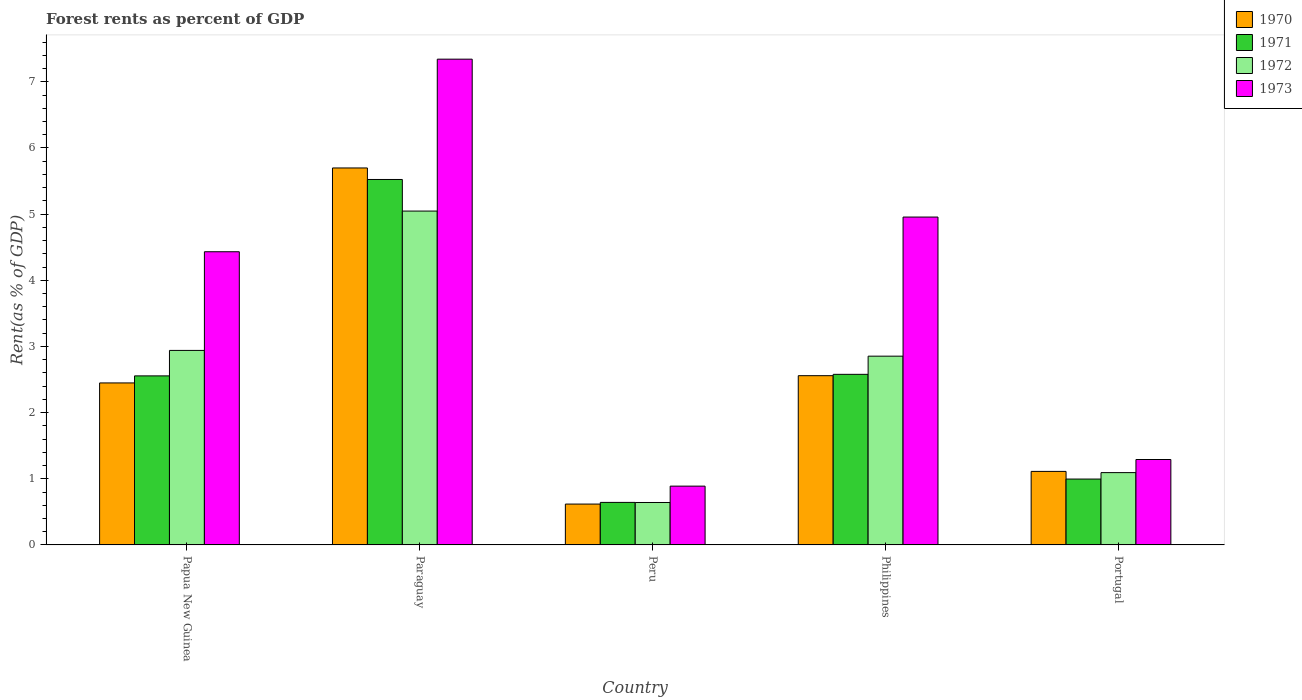How many groups of bars are there?
Your answer should be very brief. 5. How many bars are there on the 4th tick from the left?
Provide a succinct answer. 4. How many bars are there on the 2nd tick from the right?
Offer a very short reply. 4. What is the label of the 2nd group of bars from the left?
Ensure brevity in your answer.  Paraguay. In how many cases, is the number of bars for a given country not equal to the number of legend labels?
Your answer should be very brief. 0. What is the forest rent in 1970 in Paraguay?
Your response must be concise. 5.7. Across all countries, what is the maximum forest rent in 1970?
Your response must be concise. 5.7. Across all countries, what is the minimum forest rent in 1973?
Keep it short and to the point. 0.89. In which country was the forest rent in 1973 maximum?
Offer a very short reply. Paraguay. In which country was the forest rent in 1972 minimum?
Make the answer very short. Peru. What is the total forest rent in 1971 in the graph?
Give a very brief answer. 12.3. What is the difference between the forest rent in 1973 in Paraguay and that in Philippines?
Offer a very short reply. 2.39. What is the difference between the forest rent in 1971 in Paraguay and the forest rent in 1973 in Peru?
Ensure brevity in your answer.  4.64. What is the average forest rent in 1972 per country?
Ensure brevity in your answer.  2.51. What is the difference between the forest rent of/in 1973 and forest rent of/in 1970 in Paraguay?
Your answer should be very brief. 1.64. In how many countries, is the forest rent in 1973 greater than 1 %?
Your answer should be very brief. 4. What is the ratio of the forest rent in 1971 in Peru to that in Philippines?
Offer a terse response. 0.25. Is the forest rent in 1971 in Papua New Guinea less than that in Paraguay?
Give a very brief answer. Yes. Is the difference between the forest rent in 1973 in Papua New Guinea and Portugal greater than the difference between the forest rent in 1970 in Papua New Guinea and Portugal?
Your answer should be compact. Yes. What is the difference between the highest and the second highest forest rent in 1971?
Your answer should be compact. 0.02. What is the difference between the highest and the lowest forest rent in 1972?
Your answer should be very brief. 4.41. Is the sum of the forest rent in 1973 in Peru and Portugal greater than the maximum forest rent in 1970 across all countries?
Offer a terse response. No. What does the 2nd bar from the left in Philippines represents?
Offer a terse response. 1971. What is the difference between two consecutive major ticks on the Y-axis?
Make the answer very short. 1. Does the graph contain any zero values?
Ensure brevity in your answer.  No. Does the graph contain grids?
Offer a terse response. No. How many legend labels are there?
Ensure brevity in your answer.  4. What is the title of the graph?
Offer a terse response. Forest rents as percent of GDP. What is the label or title of the Y-axis?
Your answer should be compact. Rent(as % of GDP). What is the Rent(as % of GDP) of 1970 in Papua New Guinea?
Give a very brief answer. 2.45. What is the Rent(as % of GDP) of 1971 in Papua New Guinea?
Provide a succinct answer. 2.56. What is the Rent(as % of GDP) of 1972 in Papua New Guinea?
Give a very brief answer. 2.94. What is the Rent(as % of GDP) of 1973 in Papua New Guinea?
Provide a succinct answer. 4.43. What is the Rent(as % of GDP) in 1970 in Paraguay?
Provide a succinct answer. 5.7. What is the Rent(as % of GDP) of 1971 in Paraguay?
Your response must be concise. 5.52. What is the Rent(as % of GDP) of 1972 in Paraguay?
Give a very brief answer. 5.05. What is the Rent(as % of GDP) in 1973 in Paraguay?
Give a very brief answer. 7.34. What is the Rent(as % of GDP) of 1970 in Peru?
Give a very brief answer. 0.62. What is the Rent(as % of GDP) of 1971 in Peru?
Your answer should be compact. 0.64. What is the Rent(as % of GDP) of 1972 in Peru?
Give a very brief answer. 0.64. What is the Rent(as % of GDP) of 1973 in Peru?
Give a very brief answer. 0.89. What is the Rent(as % of GDP) of 1970 in Philippines?
Make the answer very short. 2.56. What is the Rent(as % of GDP) of 1971 in Philippines?
Provide a short and direct response. 2.58. What is the Rent(as % of GDP) in 1972 in Philippines?
Offer a very short reply. 2.85. What is the Rent(as % of GDP) in 1973 in Philippines?
Your answer should be compact. 4.96. What is the Rent(as % of GDP) of 1970 in Portugal?
Your answer should be compact. 1.11. What is the Rent(as % of GDP) in 1971 in Portugal?
Offer a terse response. 1. What is the Rent(as % of GDP) in 1972 in Portugal?
Ensure brevity in your answer.  1.09. What is the Rent(as % of GDP) of 1973 in Portugal?
Ensure brevity in your answer.  1.29. Across all countries, what is the maximum Rent(as % of GDP) of 1970?
Your response must be concise. 5.7. Across all countries, what is the maximum Rent(as % of GDP) in 1971?
Your answer should be compact. 5.52. Across all countries, what is the maximum Rent(as % of GDP) of 1972?
Make the answer very short. 5.05. Across all countries, what is the maximum Rent(as % of GDP) of 1973?
Offer a very short reply. 7.34. Across all countries, what is the minimum Rent(as % of GDP) of 1970?
Your response must be concise. 0.62. Across all countries, what is the minimum Rent(as % of GDP) of 1971?
Offer a very short reply. 0.64. Across all countries, what is the minimum Rent(as % of GDP) in 1972?
Keep it short and to the point. 0.64. Across all countries, what is the minimum Rent(as % of GDP) in 1973?
Make the answer very short. 0.89. What is the total Rent(as % of GDP) of 1970 in the graph?
Your answer should be compact. 12.43. What is the total Rent(as % of GDP) in 1971 in the graph?
Your answer should be compact. 12.3. What is the total Rent(as % of GDP) in 1972 in the graph?
Provide a succinct answer. 12.57. What is the total Rent(as % of GDP) of 1973 in the graph?
Keep it short and to the point. 18.91. What is the difference between the Rent(as % of GDP) in 1970 in Papua New Guinea and that in Paraguay?
Your answer should be very brief. -3.25. What is the difference between the Rent(as % of GDP) in 1971 in Papua New Guinea and that in Paraguay?
Ensure brevity in your answer.  -2.97. What is the difference between the Rent(as % of GDP) in 1972 in Papua New Guinea and that in Paraguay?
Offer a terse response. -2.11. What is the difference between the Rent(as % of GDP) in 1973 in Papua New Guinea and that in Paraguay?
Offer a terse response. -2.91. What is the difference between the Rent(as % of GDP) of 1970 in Papua New Guinea and that in Peru?
Provide a succinct answer. 1.83. What is the difference between the Rent(as % of GDP) in 1971 in Papua New Guinea and that in Peru?
Your response must be concise. 1.91. What is the difference between the Rent(as % of GDP) of 1972 in Papua New Guinea and that in Peru?
Offer a very short reply. 2.3. What is the difference between the Rent(as % of GDP) of 1973 in Papua New Guinea and that in Peru?
Provide a short and direct response. 3.54. What is the difference between the Rent(as % of GDP) in 1970 in Papua New Guinea and that in Philippines?
Keep it short and to the point. -0.11. What is the difference between the Rent(as % of GDP) of 1971 in Papua New Guinea and that in Philippines?
Make the answer very short. -0.02. What is the difference between the Rent(as % of GDP) of 1972 in Papua New Guinea and that in Philippines?
Keep it short and to the point. 0.09. What is the difference between the Rent(as % of GDP) in 1973 in Papua New Guinea and that in Philippines?
Make the answer very short. -0.52. What is the difference between the Rent(as % of GDP) in 1970 in Papua New Guinea and that in Portugal?
Keep it short and to the point. 1.34. What is the difference between the Rent(as % of GDP) of 1971 in Papua New Guinea and that in Portugal?
Make the answer very short. 1.56. What is the difference between the Rent(as % of GDP) of 1972 in Papua New Guinea and that in Portugal?
Offer a very short reply. 1.85. What is the difference between the Rent(as % of GDP) in 1973 in Papua New Guinea and that in Portugal?
Make the answer very short. 3.14. What is the difference between the Rent(as % of GDP) of 1970 in Paraguay and that in Peru?
Give a very brief answer. 5.08. What is the difference between the Rent(as % of GDP) in 1971 in Paraguay and that in Peru?
Provide a short and direct response. 4.88. What is the difference between the Rent(as % of GDP) of 1972 in Paraguay and that in Peru?
Make the answer very short. 4.41. What is the difference between the Rent(as % of GDP) of 1973 in Paraguay and that in Peru?
Provide a short and direct response. 6.45. What is the difference between the Rent(as % of GDP) in 1970 in Paraguay and that in Philippines?
Your answer should be very brief. 3.14. What is the difference between the Rent(as % of GDP) of 1971 in Paraguay and that in Philippines?
Provide a succinct answer. 2.95. What is the difference between the Rent(as % of GDP) of 1972 in Paraguay and that in Philippines?
Ensure brevity in your answer.  2.19. What is the difference between the Rent(as % of GDP) in 1973 in Paraguay and that in Philippines?
Keep it short and to the point. 2.39. What is the difference between the Rent(as % of GDP) in 1970 in Paraguay and that in Portugal?
Provide a short and direct response. 4.59. What is the difference between the Rent(as % of GDP) of 1971 in Paraguay and that in Portugal?
Provide a succinct answer. 4.53. What is the difference between the Rent(as % of GDP) in 1972 in Paraguay and that in Portugal?
Keep it short and to the point. 3.95. What is the difference between the Rent(as % of GDP) of 1973 in Paraguay and that in Portugal?
Make the answer very short. 6.05. What is the difference between the Rent(as % of GDP) of 1970 in Peru and that in Philippines?
Offer a terse response. -1.94. What is the difference between the Rent(as % of GDP) of 1971 in Peru and that in Philippines?
Offer a terse response. -1.94. What is the difference between the Rent(as % of GDP) of 1972 in Peru and that in Philippines?
Make the answer very short. -2.21. What is the difference between the Rent(as % of GDP) of 1973 in Peru and that in Philippines?
Ensure brevity in your answer.  -4.07. What is the difference between the Rent(as % of GDP) of 1970 in Peru and that in Portugal?
Provide a succinct answer. -0.49. What is the difference between the Rent(as % of GDP) of 1971 in Peru and that in Portugal?
Provide a succinct answer. -0.35. What is the difference between the Rent(as % of GDP) of 1972 in Peru and that in Portugal?
Make the answer very short. -0.45. What is the difference between the Rent(as % of GDP) in 1973 in Peru and that in Portugal?
Your answer should be compact. -0.4. What is the difference between the Rent(as % of GDP) in 1970 in Philippines and that in Portugal?
Your answer should be compact. 1.45. What is the difference between the Rent(as % of GDP) in 1971 in Philippines and that in Portugal?
Ensure brevity in your answer.  1.58. What is the difference between the Rent(as % of GDP) in 1972 in Philippines and that in Portugal?
Offer a very short reply. 1.76. What is the difference between the Rent(as % of GDP) of 1973 in Philippines and that in Portugal?
Offer a very short reply. 3.66. What is the difference between the Rent(as % of GDP) of 1970 in Papua New Guinea and the Rent(as % of GDP) of 1971 in Paraguay?
Give a very brief answer. -3.08. What is the difference between the Rent(as % of GDP) in 1970 in Papua New Guinea and the Rent(as % of GDP) in 1972 in Paraguay?
Ensure brevity in your answer.  -2.6. What is the difference between the Rent(as % of GDP) of 1970 in Papua New Guinea and the Rent(as % of GDP) of 1973 in Paraguay?
Your answer should be compact. -4.89. What is the difference between the Rent(as % of GDP) of 1971 in Papua New Guinea and the Rent(as % of GDP) of 1972 in Paraguay?
Your answer should be compact. -2.49. What is the difference between the Rent(as % of GDP) of 1971 in Papua New Guinea and the Rent(as % of GDP) of 1973 in Paraguay?
Provide a succinct answer. -4.79. What is the difference between the Rent(as % of GDP) in 1972 in Papua New Guinea and the Rent(as % of GDP) in 1973 in Paraguay?
Provide a succinct answer. -4.4. What is the difference between the Rent(as % of GDP) of 1970 in Papua New Guinea and the Rent(as % of GDP) of 1971 in Peru?
Offer a terse response. 1.81. What is the difference between the Rent(as % of GDP) in 1970 in Papua New Guinea and the Rent(as % of GDP) in 1972 in Peru?
Offer a very short reply. 1.81. What is the difference between the Rent(as % of GDP) in 1970 in Papua New Guinea and the Rent(as % of GDP) in 1973 in Peru?
Provide a succinct answer. 1.56. What is the difference between the Rent(as % of GDP) in 1971 in Papua New Guinea and the Rent(as % of GDP) in 1972 in Peru?
Provide a succinct answer. 1.91. What is the difference between the Rent(as % of GDP) of 1972 in Papua New Guinea and the Rent(as % of GDP) of 1973 in Peru?
Give a very brief answer. 2.05. What is the difference between the Rent(as % of GDP) in 1970 in Papua New Guinea and the Rent(as % of GDP) in 1971 in Philippines?
Make the answer very short. -0.13. What is the difference between the Rent(as % of GDP) in 1970 in Papua New Guinea and the Rent(as % of GDP) in 1972 in Philippines?
Your answer should be very brief. -0.4. What is the difference between the Rent(as % of GDP) of 1970 in Papua New Guinea and the Rent(as % of GDP) of 1973 in Philippines?
Provide a short and direct response. -2.51. What is the difference between the Rent(as % of GDP) in 1971 in Papua New Guinea and the Rent(as % of GDP) in 1972 in Philippines?
Ensure brevity in your answer.  -0.3. What is the difference between the Rent(as % of GDP) of 1971 in Papua New Guinea and the Rent(as % of GDP) of 1973 in Philippines?
Provide a succinct answer. -2.4. What is the difference between the Rent(as % of GDP) of 1972 in Papua New Guinea and the Rent(as % of GDP) of 1973 in Philippines?
Your response must be concise. -2.02. What is the difference between the Rent(as % of GDP) in 1970 in Papua New Guinea and the Rent(as % of GDP) in 1971 in Portugal?
Your answer should be compact. 1.45. What is the difference between the Rent(as % of GDP) of 1970 in Papua New Guinea and the Rent(as % of GDP) of 1972 in Portugal?
Make the answer very short. 1.36. What is the difference between the Rent(as % of GDP) of 1970 in Papua New Guinea and the Rent(as % of GDP) of 1973 in Portugal?
Offer a terse response. 1.16. What is the difference between the Rent(as % of GDP) of 1971 in Papua New Guinea and the Rent(as % of GDP) of 1972 in Portugal?
Ensure brevity in your answer.  1.46. What is the difference between the Rent(as % of GDP) in 1971 in Papua New Guinea and the Rent(as % of GDP) in 1973 in Portugal?
Provide a short and direct response. 1.26. What is the difference between the Rent(as % of GDP) of 1972 in Papua New Guinea and the Rent(as % of GDP) of 1973 in Portugal?
Ensure brevity in your answer.  1.65. What is the difference between the Rent(as % of GDP) in 1970 in Paraguay and the Rent(as % of GDP) in 1971 in Peru?
Ensure brevity in your answer.  5.06. What is the difference between the Rent(as % of GDP) in 1970 in Paraguay and the Rent(as % of GDP) in 1972 in Peru?
Your response must be concise. 5.06. What is the difference between the Rent(as % of GDP) in 1970 in Paraguay and the Rent(as % of GDP) in 1973 in Peru?
Your answer should be very brief. 4.81. What is the difference between the Rent(as % of GDP) of 1971 in Paraguay and the Rent(as % of GDP) of 1972 in Peru?
Your answer should be very brief. 4.88. What is the difference between the Rent(as % of GDP) of 1971 in Paraguay and the Rent(as % of GDP) of 1973 in Peru?
Keep it short and to the point. 4.64. What is the difference between the Rent(as % of GDP) in 1972 in Paraguay and the Rent(as % of GDP) in 1973 in Peru?
Make the answer very short. 4.16. What is the difference between the Rent(as % of GDP) in 1970 in Paraguay and the Rent(as % of GDP) in 1971 in Philippines?
Provide a succinct answer. 3.12. What is the difference between the Rent(as % of GDP) in 1970 in Paraguay and the Rent(as % of GDP) in 1972 in Philippines?
Offer a very short reply. 2.84. What is the difference between the Rent(as % of GDP) in 1970 in Paraguay and the Rent(as % of GDP) in 1973 in Philippines?
Offer a terse response. 0.74. What is the difference between the Rent(as % of GDP) of 1971 in Paraguay and the Rent(as % of GDP) of 1972 in Philippines?
Provide a succinct answer. 2.67. What is the difference between the Rent(as % of GDP) of 1971 in Paraguay and the Rent(as % of GDP) of 1973 in Philippines?
Ensure brevity in your answer.  0.57. What is the difference between the Rent(as % of GDP) of 1972 in Paraguay and the Rent(as % of GDP) of 1973 in Philippines?
Give a very brief answer. 0.09. What is the difference between the Rent(as % of GDP) of 1970 in Paraguay and the Rent(as % of GDP) of 1971 in Portugal?
Give a very brief answer. 4.7. What is the difference between the Rent(as % of GDP) in 1970 in Paraguay and the Rent(as % of GDP) in 1972 in Portugal?
Make the answer very short. 4.61. What is the difference between the Rent(as % of GDP) in 1970 in Paraguay and the Rent(as % of GDP) in 1973 in Portugal?
Provide a succinct answer. 4.41. What is the difference between the Rent(as % of GDP) of 1971 in Paraguay and the Rent(as % of GDP) of 1972 in Portugal?
Provide a succinct answer. 4.43. What is the difference between the Rent(as % of GDP) of 1971 in Paraguay and the Rent(as % of GDP) of 1973 in Portugal?
Your response must be concise. 4.23. What is the difference between the Rent(as % of GDP) in 1972 in Paraguay and the Rent(as % of GDP) in 1973 in Portugal?
Your answer should be very brief. 3.76. What is the difference between the Rent(as % of GDP) in 1970 in Peru and the Rent(as % of GDP) in 1971 in Philippines?
Offer a terse response. -1.96. What is the difference between the Rent(as % of GDP) of 1970 in Peru and the Rent(as % of GDP) of 1972 in Philippines?
Your response must be concise. -2.24. What is the difference between the Rent(as % of GDP) of 1970 in Peru and the Rent(as % of GDP) of 1973 in Philippines?
Provide a succinct answer. -4.34. What is the difference between the Rent(as % of GDP) of 1971 in Peru and the Rent(as % of GDP) of 1972 in Philippines?
Keep it short and to the point. -2.21. What is the difference between the Rent(as % of GDP) of 1971 in Peru and the Rent(as % of GDP) of 1973 in Philippines?
Your answer should be compact. -4.31. What is the difference between the Rent(as % of GDP) in 1972 in Peru and the Rent(as % of GDP) in 1973 in Philippines?
Your response must be concise. -4.31. What is the difference between the Rent(as % of GDP) in 1970 in Peru and the Rent(as % of GDP) in 1971 in Portugal?
Provide a succinct answer. -0.38. What is the difference between the Rent(as % of GDP) of 1970 in Peru and the Rent(as % of GDP) of 1972 in Portugal?
Provide a short and direct response. -0.48. What is the difference between the Rent(as % of GDP) in 1970 in Peru and the Rent(as % of GDP) in 1973 in Portugal?
Your response must be concise. -0.67. What is the difference between the Rent(as % of GDP) in 1971 in Peru and the Rent(as % of GDP) in 1972 in Portugal?
Offer a terse response. -0.45. What is the difference between the Rent(as % of GDP) in 1971 in Peru and the Rent(as % of GDP) in 1973 in Portugal?
Your answer should be compact. -0.65. What is the difference between the Rent(as % of GDP) in 1972 in Peru and the Rent(as % of GDP) in 1973 in Portugal?
Keep it short and to the point. -0.65. What is the difference between the Rent(as % of GDP) in 1970 in Philippines and the Rent(as % of GDP) in 1971 in Portugal?
Your answer should be compact. 1.56. What is the difference between the Rent(as % of GDP) in 1970 in Philippines and the Rent(as % of GDP) in 1972 in Portugal?
Offer a terse response. 1.47. What is the difference between the Rent(as % of GDP) in 1970 in Philippines and the Rent(as % of GDP) in 1973 in Portugal?
Your answer should be compact. 1.27. What is the difference between the Rent(as % of GDP) in 1971 in Philippines and the Rent(as % of GDP) in 1972 in Portugal?
Provide a short and direct response. 1.49. What is the difference between the Rent(as % of GDP) of 1971 in Philippines and the Rent(as % of GDP) of 1973 in Portugal?
Your response must be concise. 1.29. What is the difference between the Rent(as % of GDP) of 1972 in Philippines and the Rent(as % of GDP) of 1973 in Portugal?
Provide a short and direct response. 1.56. What is the average Rent(as % of GDP) of 1970 per country?
Your answer should be very brief. 2.49. What is the average Rent(as % of GDP) of 1971 per country?
Provide a succinct answer. 2.46. What is the average Rent(as % of GDP) in 1972 per country?
Give a very brief answer. 2.52. What is the average Rent(as % of GDP) of 1973 per country?
Offer a very short reply. 3.78. What is the difference between the Rent(as % of GDP) in 1970 and Rent(as % of GDP) in 1971 in Papua New Guinea?
Make the answer very short. -0.11. What is the difference between the Rent(as % of GDP) in 1970 and Rent(as % of GDP) in 1972 in Papua New Guinea?
Your answer should be compact. -0.49. What is the difference between the Rent(as % of GDP) in 1970 and Rent(as % of GDP) in 1973 in Papua New Guinea?
Your answer should be compact. -1.98. What is the difference between the Rent(as % of GDP) of 1971 and Rent(as % of GDP) of 1972 in Papua New Guinea?
Offer a very short reply. -0.38. What is the difference between the Rent(as % of GDP) of 1971 and Rent(as % of GDP) of 1973 in Papua New Guinea?
Give a very brief answer. -1.88. What is the difference between the Rent(as % of GDP) in 1972 and Rent(as % of GDP) in 1973 in Papua New Guinea?
Your answer should be very brief. -1.49. What is the difference between the Rent(as % of GDP) in 1970 and Rent(as % of GDP) in 1971 in Paraguay?
Your answer should be very brief. 0.17. What is the difference between the Rent(as % of GDP) of 1970 and Rent(as % of GDP) of 1972 in Paraguay?
Your answer should be very brief. 0.65. What is the difference between the Rent(as % of GDP) in 1970 and Rent(as % of GDP) in 1973 in Paraguay?
Give a very brief answer. -1.64. What is the difference between the Rent(as % of GDP) in 1971 and Rent(as % of GDP) in 1972 in Paraguay?
Ensure brevity in your answer.  0.48. What is the difference between the Rent(as % of GDP) in 1971 and Rent(as % of GDP) in 1973 in Paraguay?
Provide a short and direct response. -1.82. What is the difference between the Rent(as % of GDP) in 1972 and Rent(as % of GDP) in 1973 in Paraguay?
Give a very brief answer. -2.3. What is the difference between the Rent(as % of GDP) of 1970 and Rent(as % of GDP) of 1971 in Peru?
Your answer should be compact. -0.03. What is the difference between the Rent(as % of GDP) in 1970 and Rent(as % of GDP) in 1972 in Peru?
Provide a short and direct response. -0.02. What is the difference between the Rent(as % of GDP) of 1970 and Rent(as % of GDP) of 1973 in Peru?
Keep it short and to the point. -0.27. What is the difference between the Rent(as % of GDP) of 1971 and Rent(as % of GDP) of 1972 in Peru?
Provide a short and direct response. 0. What is the difference between the Rent(as % of GDP) of 1971 and Rent(as % of GDP) of 1973 in Peru?
Your answer should be compact. -0.25. What is the difference between the Rent(as % of GDP) of 1972 and Rent(as % of GDP) of 1973 in Peru?
Your answer should be very brief. -0.25. What is the difference between the Rent(as % of GDP) in 1970 and Rent(as % of GDP) in 1971 in Philippines?
Keep it short and to the point. -0.02. What is the difference between the Rent(as % of GDP) of 1970 and Rent(as % of GDP) of 1972 in Philippines?
Your response must be concise. -0.29. What is the difference between the Rent(as % of GDP) of 1970 and Rent(as % of GDP) of 1973 in Philippines?
Provide a succinct answer. -2.4. What is the difference between the Rent(as % of GDP) in 1971 and Rent(as % of GDP) in 1972 in Philippines?
Offer a very short reply. -0.27. What is the difference between the Rent(as % of GDP) in 1971 and Rent(as % of GDP) in 1973 in Philippines?
Offer a very short reply. -2.38. What is the difference between the Rent(as % of GDP) in 1972 and Rent(as % of GDP) in 1973 in Philippines?
Offer a terse response. -2.1. What is the difference between the Rent(as % of GDP) of 1970 and Rent(as % of GDP) of 1971 in Portugal?
Offer a terse response. 0.12. What is the difference between the Rent(as % of GDP) of 1970 and Rent(as % of GDP) of 1972 in Portugal?
Provide a succinct answer. 0.02. What is the difference between the Rent(as % of GDP) in 1970 and Rent(as % of GDP) in 1973 in Portugal?
Ensure brevity in your answer.  -0.18. What is the difference between the Rent(as % of GDP) in 1971 and Rent(as % of GDP) in 1972 in Portugal?
Make the answer very short. -0.1. What is the difference between the Rent(as % of GDP) of 1971 and Rent(as % of GDP) of 1973 in Portugal?
Provide a succinct answer. -0.3. What is the difference between the Rent(as % of GDP) in 1972 and Rent(as % of GDP) in 1973 in Portugal?
Offer a terse response. -0.2. What is the ratio of the Rent(as % of GDP) in 1970 in Papua New Guinea to that in Paraguay?
Your answer should be very brief. 0.43. What is the ratio of the Rent(as % of GDP) in 1971 in Papua New Guinea to that in Paraguay?
Keep it short and to the point. 0.46. What is the ratio of the Rent(as % of GDP) of 1972 in Papua New Guinea to that in Paraguay?
Give a very brief answer. 0.58. What is the ratio of the Rent(as % of GDP) in 1973 in Papua New Guinea to that in Paraguay?
Provide a short and direct response. 0.6. What is the ratio of the Rent(as % of GDP) in 1970 in Papua New Guinea to that in Peru?
Your answer should be compact. 3.96. What is the ratio of the Rent(as % of GDP) in 1971 in Papua New Guinea to that in Peru?
Provide a succinct answer. 3.97. What is the ratio of the Rent(as % of GDP) in 1972 in Papua New Guinea to that in Peru?
Your response must be concise. 4.58. What is the ratio of the Rent(as % of GDP) in 1973 in Papua New Guinea to that in Peru?
Keep it short and to the point. 4.99. What is the ratio of the Rent(as % of GDP) in 1970 in Papua New Guinea to that in Philippines?
Offer a very short reply. 0.96. What is the ratio of the Rent(as % of GDP) in 1972 in Papua New Guinea to that in Philippines?
Make the answer very short. 1.03. What is the ratio of the Rent(as % of GDP) in 1973 in Papua New Guinea to that in Philippines?
Make the answer very short. 0.89. What is the ratio of the Rent(as % of GDP) in 1970 in Papua New Guinea to that in Portugal?
Your answer should be very brief. 2.2. What is the ratio of the Rent(as % of GDP) of 1971 in Papua New Guinea to that in Portugal?
Provide a succinct answer. 2.57. What is the ratio of the Rent(as % of GDP) of 1972 in Papua New Guinea to that in Portugal?
Offer a terse response. 2.69. What is the ratio of the Rent(as % of GDP) in 1973 in Papua New Guinea to that in Portugal?
Offer a very short reply. 3.43. What is the ratio of the Rent(as % of GDP) of 1970 in Paraguay to that in Peru?
Your answer should be compact. 9.23. What is the ratio of the Rent(as % of GDP) in 1971 in Paraguay to that in Peru?
Your response must be concise. 8.59. What is the ratio of the Rent(as % of GDP) of 1972 in Paraguay to that in Peru?
Provide a succinct answer. 7.87. What is the ratio of the Rent(as % of GDP) in 1973 in Paraguay to that in Peru?
Make the answer very short. 8.26. What is the ratio of the Rent(as % of GDP) in 1970 in Paraguay to that in Philippines?
Your answer should be very brief. 2.23. What is the ratio of the Rent(as % of GDP) in 1971 in Paraguay to that in Philippines?
Make the answer very short. 2.14. What is the ratio of the Rent(as % of GDP) of 1972 in Paraguay to that in Philippines?
Your response must be concise. 1.77. What is the ratio of the Rent(as % of GDP) of 1973 in Paraguay to that in Philippines?
Your answer should be compact. 1.48. What is the ratio of the Rent(as % of GDP) in 1970 in Paraguay to that in Portugal?
Offer a terse response. 5.13. What is the ratio of the Rent(as % of GDP) in 1971 in Paraguay to that in Portugal?
Offer a terse response. 5.55. What is the ratio of the Rent(as % of GDP) in 1972 in Paraguay to that in Portugal?
Your answer should be very brief. 4.62. What is the ratio of the Rent(as % of GDP) in 1973 in Paraguay to that in Portugal?
Your answer should be very brief. 5.69. What is the ratio of the Rent(as % of GDP) of 1970 in Peru to that in Philippines?
Give a very brief answer. 0.24. What is the ratio of the Rent(as % of GDP) of 1971 in Peru to that in Philippines?
Provide a short and direct response. 0.25. What is the ratio of the Rent(as % of GDP) of 1972 in Peru to that in Philippines?
Your response must be concise. 0.22. What is the ratio of the Rent(as % of GDP) in 1973 in Peru to that in Philippines?
Offer a terse response. 0.18. What is the ratio of the Rent(as % of GDP) of 1970 in Peru to that in Portugal?
Offer a terse response. 0.56. What is the ratio of the Rent(as % of GDP) in 1971 in Peru to that in Portugal?
Keep it short and to the point. 0.65. What is the ratio of the Rent(as % of GDP) in 1972 in Peru to that in Portugal?
Your response must be concise. 0.59. What is the ratio of the Rent(as % of GDP) of 1973 in Peru to that in Portugal?
Your response must be concise. 0.69. What is the ratio of the Rent(as % of GDP) in 1970 in Philippines to that in Portugal?
Make the answer very short. 2.3. What is the ratio of the Rent(as % of GDP) of 1971 in Philippines to that in Portugal?
Ensure brevity in your answer.  2.59. What is the ratio of the Rent(as % of GDP) of 1972 in Philippines to that in Portugal?
Give a very brief answer. 2.61. What is the ratio of the Rent(as % of GDP) of 1973 in Philippines to that in Portugal?
Provide a short and direct response. 3.84. What is the difference between the highest and the second highest Rent(as % of GDP) of 1970?
Provide a short and direct response. 3.14. What is the difference between the highest and the second highest Rent(as % of GDP) in 1971?
Keep it short and to the point. 2.95. What is the difference between the highest and the second highest Rent(as % of GDP) of 1972?
Keep it short and to the point. 2.11. What is the difference between the highest and the second highest Rent(as % of GDP) of 1973?
Offer a terse response. 2.39. What is the difference between the highest and the lowest Rent(as % of GDP) of 1970?
Your answer should be compact. 5.08. What is the difference between the highest and the lowest Rent(as % of GDP) in 1971?
Ensure brevity in your answer.  4.88. What is the difference between the highest and the lowest Rent(as % of GDP) in 1972?
Provide a succinct answer. 4.41. What is the difference between the highest and the lowest Rent(as % of GDP) of 1973?
Your answer should be very brief. 6.45. 